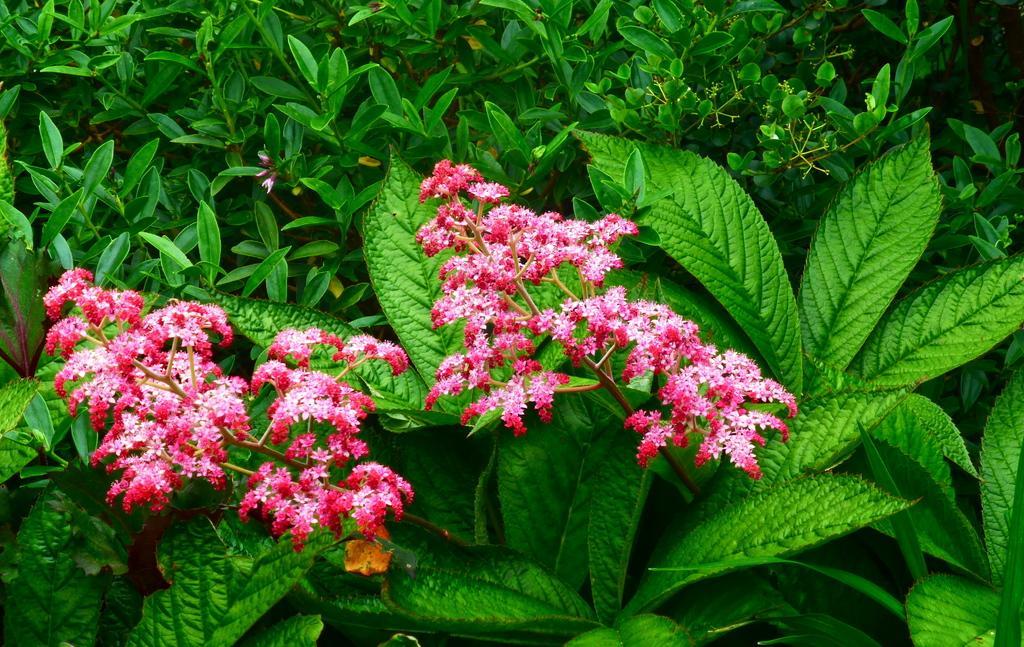Could you give a brief overview of what you see in this image? In this image I can see few flowers in pink color. In the background I can see few plants in green color. 